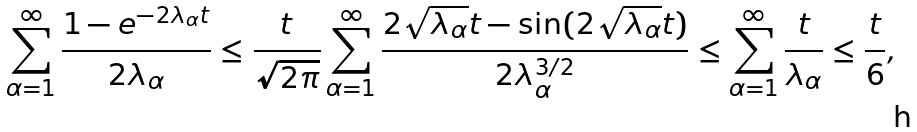<formula> <loc_0><loc_0><loc_500><loc_500>\sum _ { \alpha = 1 } ^ { \infty } \frac { 1 - e ^ { - 2 \lambda _ { \alpha } t } } { 2 \lambda _ { \alpha } } \leq \frac { t } { \sqrt { 2 \pi } } \sum _ { \alpha = 1 } ^ { \infty } \frac { 2 \sqrt { \lambda _ { \alpha } } t - \sin ( 2 \sqrt { \lambda _ { \alpha } } t ) } { 2 \lambda _ { \alpha } ^ { 3 / 2 } } \leq \sum _ { \alpha = 1 } ^ { \infty } \frac { t } { \lambda _ { \alpha } } \leq \frac { t } { 6 } ,</formula> 